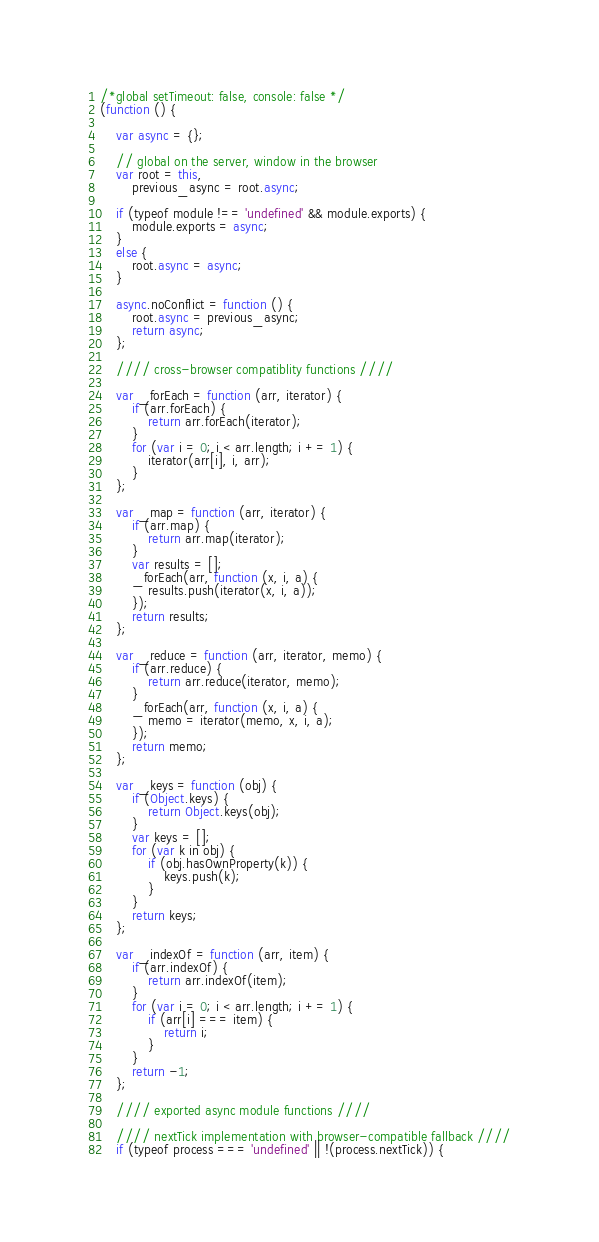Convert code to text. <code><loc_0><loc_0><loc_500><loc_500><_JavaScript_>/*global setTimeout: false, console: false */
(function () {

    var async = {};

    // global on the server, window in the browser
    var root = this,
        previous_async = root.async;

    if (typeof module !== 'undefined' && module.exports) {
        module.exports = async;
    }
    else {
        root.async = async;
    }

    async.noConflict = function () {
        root.async = previous_async;
        return async;
    };

    //// cross-browser compatiblity functions ////

    var _forEach = function (arr, iterator) {
        if (arr.forEach) {
            return arr.forEach(iterator);
        }
        for (var i = 0; i < arr.length; i += 1) {
            iterator(arr[i], i, arr);
        }
    };

    var _map = function (arr, iterator) {
        if (arr.map) {
            return arr.map(iterator);
        }
        var results = [];
        _forEach(arr, function (x, i, a) {
            results.push(iterator(x, i, a));
        });
        return results;
    };

    var _reduce = function (arr, iterator, memo) {
        if (arr.reduce) {
            return arr.reduce(iterator, memo);
        }
        _forEach(arr, function (x, i, a) {
            memo = iterator(memo, x, i, a);
        });
        return memo;
    };

    var _keys = function (obj) {
        if (Object.keys) {
            return Object.keys(obj);
        }
        var keys = [];
        for (var k in obj) {
            if (obj.hasOwnProperty(k)) {
                keys.push(k);
            }
        }
        return keys;
    };

    var _indexOf = function (arr, item) {
        if (arr.indexOf) {
            return arr.indexOf(item);
        }
        for (var i = 0; i < arr.length; i += 1) {
            if (arr[i] === item) {
                return i;
            }
        }
        return -1;
    };

    //// exported async module functions ////

    //// nextTick implementation with browser-compatible fallback ////
    if (typeof process === 'undefined' || !(process.nextTick)) {</code> 